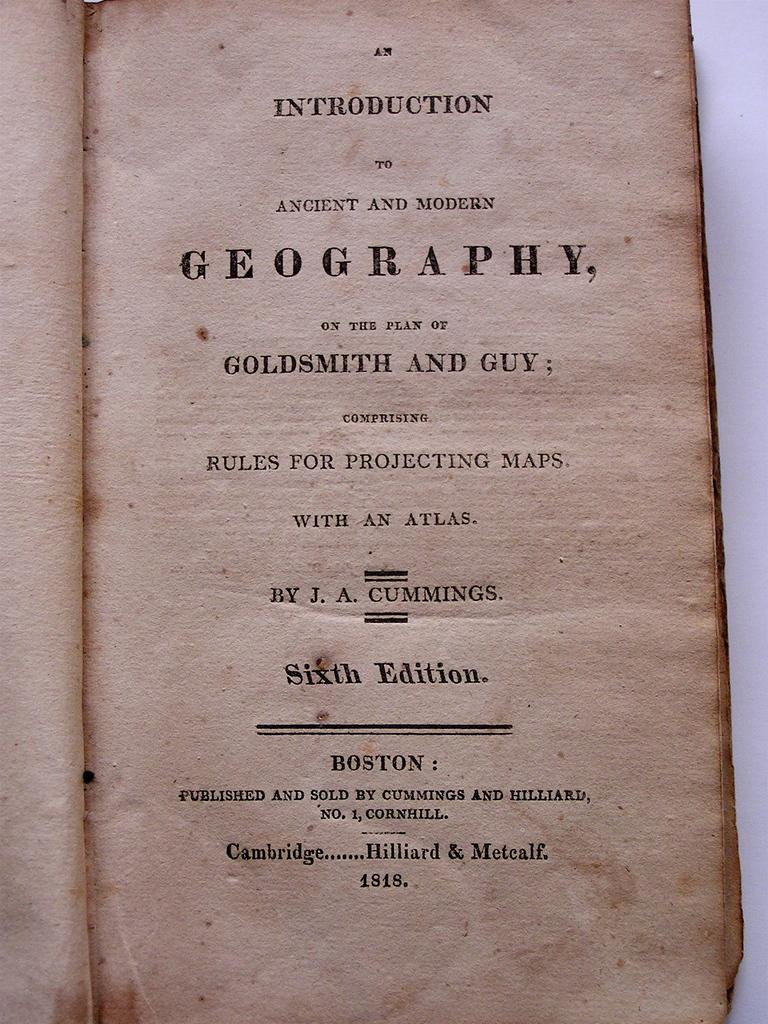This is about what science?
Provide a succinct answer. Geography. What word is written at the very top of the page of the book?
Provide a succinct answer. An. 